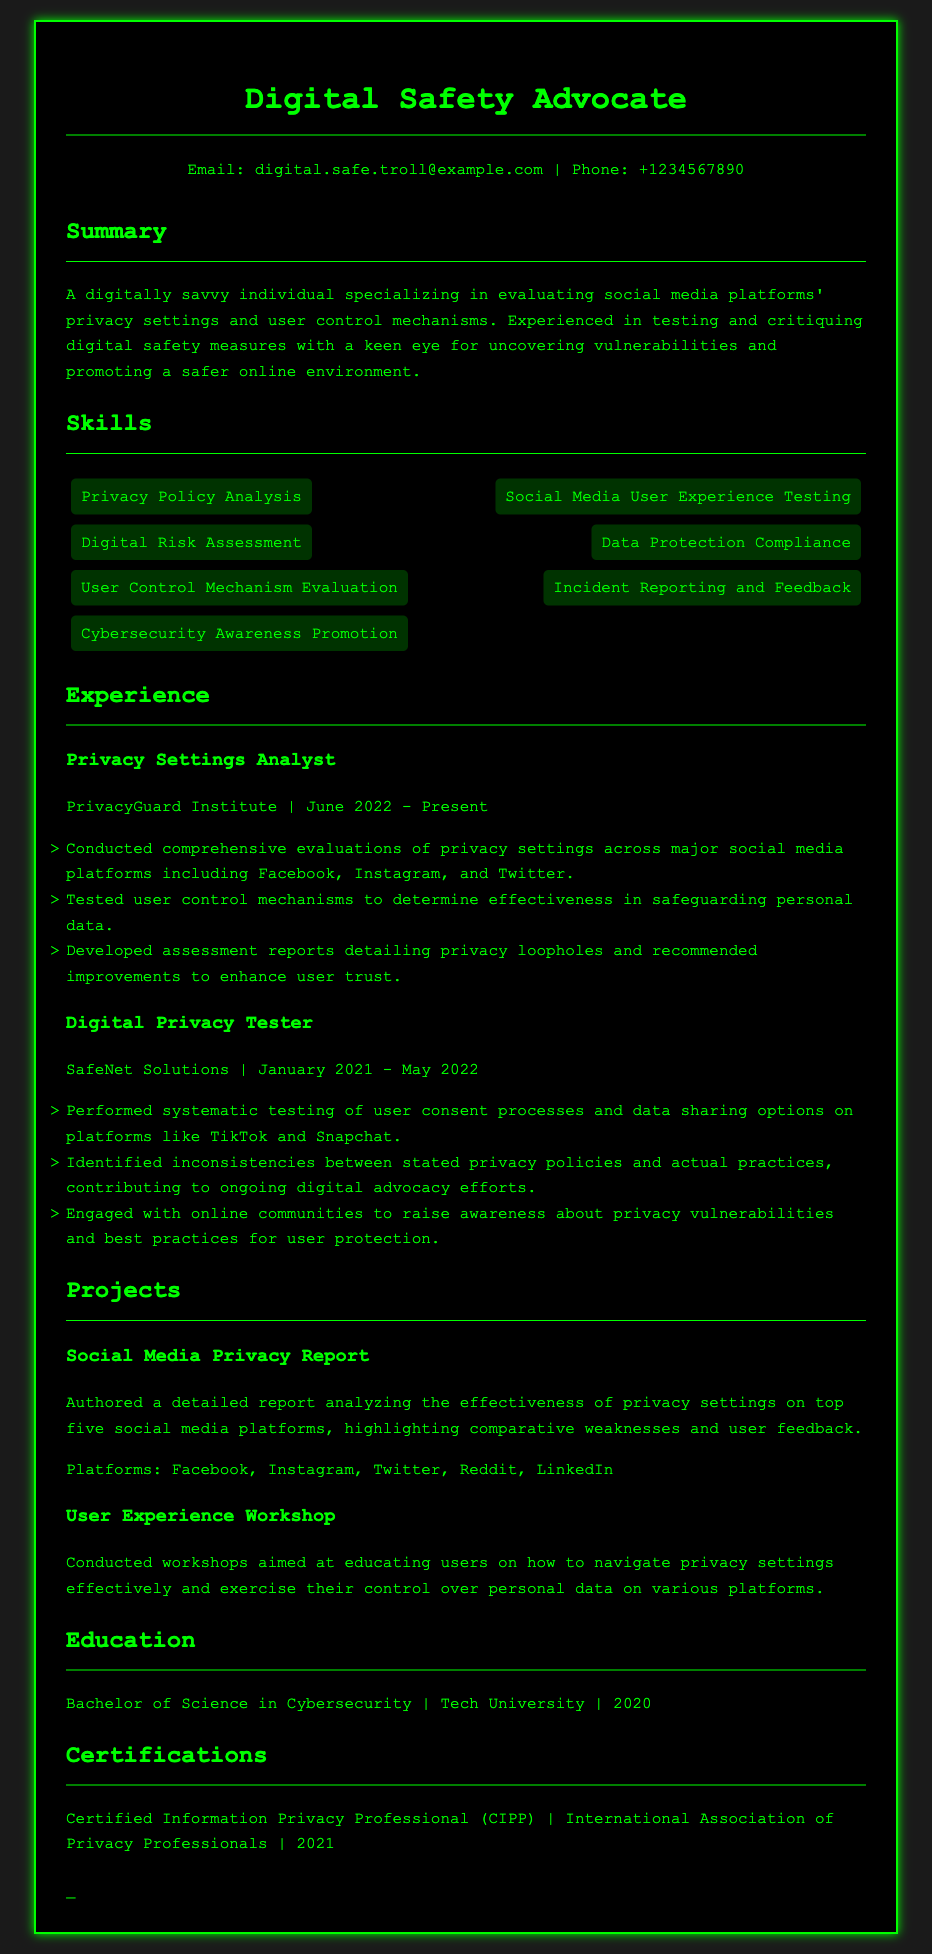what is the individual’s current job title? The current job title can be found in the Experience section and refers to the position held at the PrivacyGuard Institute.
Answer: Privacy Settings Analyst which organization did the individual work for prior to the current one? The previous organization is listed in the Experience section directly before the current role held at PrivacyGuard Institute.
Answer: SafeNet Solutions what degree does the individual hold? The degree is mentioned in the Education section, indicating the educational background of the individual.
Answer: Bachelor of Science in Cybersecurity in what year did the individual obtain their certification? The certification year is specified in the Certifications section, indicating when the individual received official recognition in privacy professionalism.
Answer: 2021 how many social media platforms were analyzed in the individual’s project report? The number of platforms is stated in the Projects section discussing the Social Media Privacy Report authored by the individual.
Answer: Five what skill is related to assessing user control mechanisms? The Skills section lists various skills, one of which pertains specifically to evaluating user control mechanisms.
Answer: User Control Mechanism Evaluation during which months of 2022 did the individual start their current job? The start date is indicated in the Experience section for the individual's current position.
Answer: June what was one focus of the User Experience Workshop project? The focus of the project is detailed in the Projects section, highlighting the purpose of conducting the workshops.
Answer: Educating users on how to navigate privacy settings effectively 